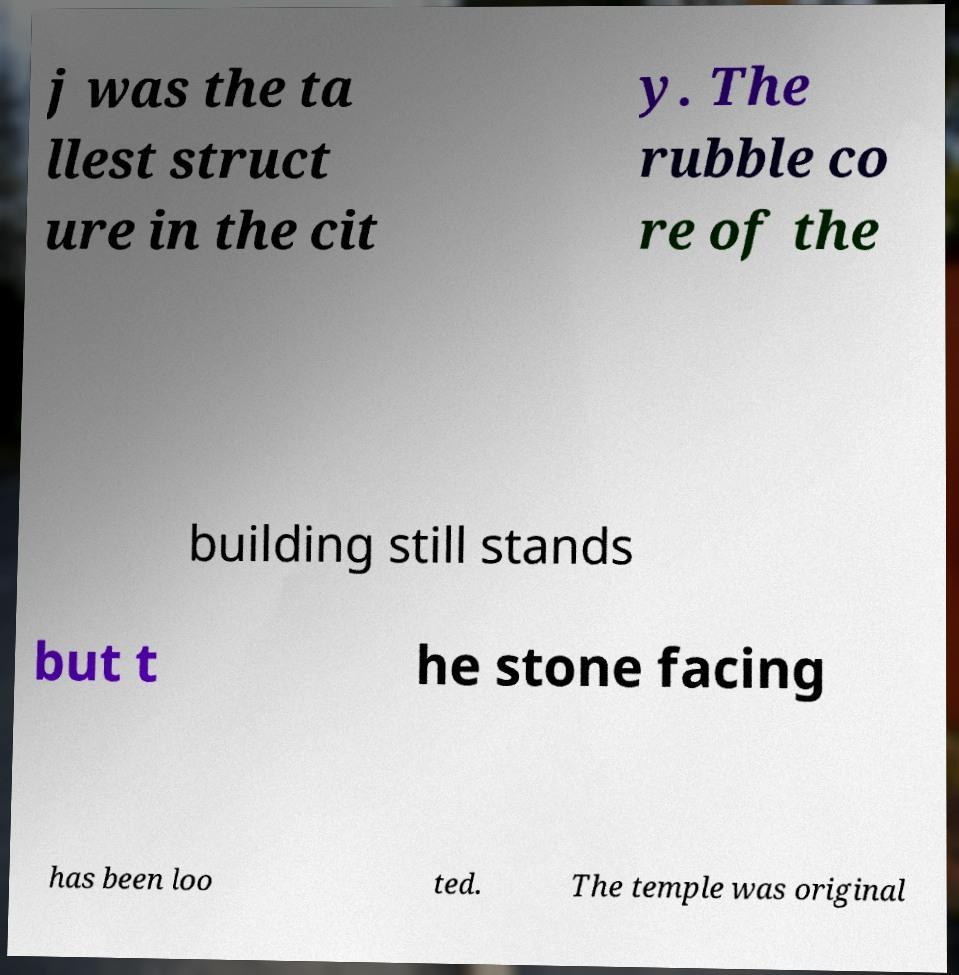Could you extract and type out the text from this image? j was the ta llest struct ure in the cit y. The rubble co re of the building still stands but t he stone facing has been loo ted. The temple was original 